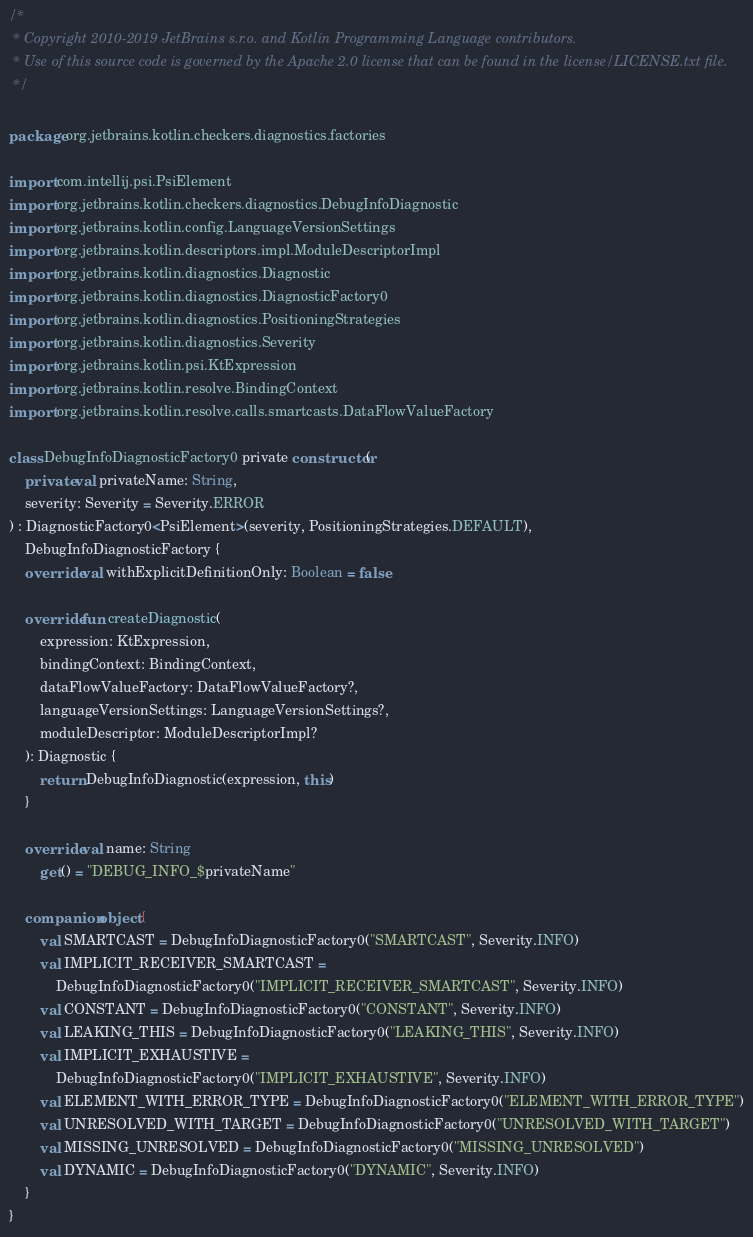<code> <loc_0><loc_0><loc_500><loc_500><_Kotlin_>/*
 * Copyright 2010-2019 JetBrains s.r.o. and Kotlin Programming Language contributors.
 * Use of this source code is governed by the Apache 2.0 license that can be found in the license/LICENSE.txt file.
 */

package org.jetbrains.kotlin.checkers.diagnostics.factories

import com.intellij.psi.PsiElement
import org.jetbrains.kotlin.checkers.diagnostics.DebugInfoDiagnostic
import org.jetbrains.kotlin.config.LanguageVersionSettings
import org.jetbrains.kotlin.descriptors.impl.ModuleDescriptorImpl
import org.jetbrains.kotlin.diagnostics.Diagnostic
import org.jetbrains.kotlin.diagnostics.DiagnosticFactory0
import org.jetbrains.kotlin.diagnostics.PositioningStrategies
import org.jetbrains.kotlin.diagnostics.Severity
import org.jetbrains.kotlin.psi.KtExpression
import org.jetbrains.kotlin.resolve.BindingContext
import org.jetbrains.kotlin.resolve.calls.smartcasts.DataFlowValueFactory

class DebugInfoDiagnosticFactory0 private constructor(
    private val privateName: String,
    severity: Severity = Severity.ERROR
) : DiagnosticFactory0<PsiElement>(severity, PositioningStrategies.DEFAULT),
    DebugInfoDiagnosticFactory {
    override val withExplicitDefinitionOnly: Boolean = false

    override fun createDiagnostic(
        expression: KtExpression,
        bindingContext: BindingContext,
        dataFlowValueFactory: DataFlowValueFactory?,
        languageVersionSettings: LanguageVersionSettings?,
        moduleDescriptor: ModuleDescriptorImpl?
    ): Diagnostic {
        return DebugInfoDiagnostic(expression, this)
    }

    override val name: String
        get() = "DEBUG_INFO_$privateName"

    companion object {
        val SMARTCAST = DebugInfoDiagnosticFactory0("SMARTCAST", Severity.INFO)
        val IMPLICIT_RECEIVER_SMARTCAST =
            DebugInfoDiagnosticFactory0("IMPLICIT_RECEIVER_SMARTCAST", Severity.INFO)
        val CONSTANT = DebugInfoDiagnosticFactory0("CONSTANT", Severity.INFO)
        val LEAKING_THIS = DebugInfoDiagnosticFactory0("LEAKING_THIS", Severity.INFO)
        val IMPLICIT_EXHAUSTIVE =
            DebugInfoDiagnosticFactory0("IMPLICIT_EXHAUSTIVE", Severity.INFO)
        val ELEMENT_WITH_ERROR_TYPE = DebugInfoDiagnosticFactory0("ELEMENT_WITH_ERROR_TYPE")
        val UNRESOLVED_WITH_TARGET = DebugInfoDiagnosticFactory0("UNRESOLVED_WITH_TARGET")
        val MISSING_UNRESOLVED = DebugInfoDiagnosticFactory0("MISSING_UNRESOLVED")
        val DYNAMIC = DebugInfoDiagnosticFactory0("DYNAMIC", Severity.INFO)
    }
}
</code> 